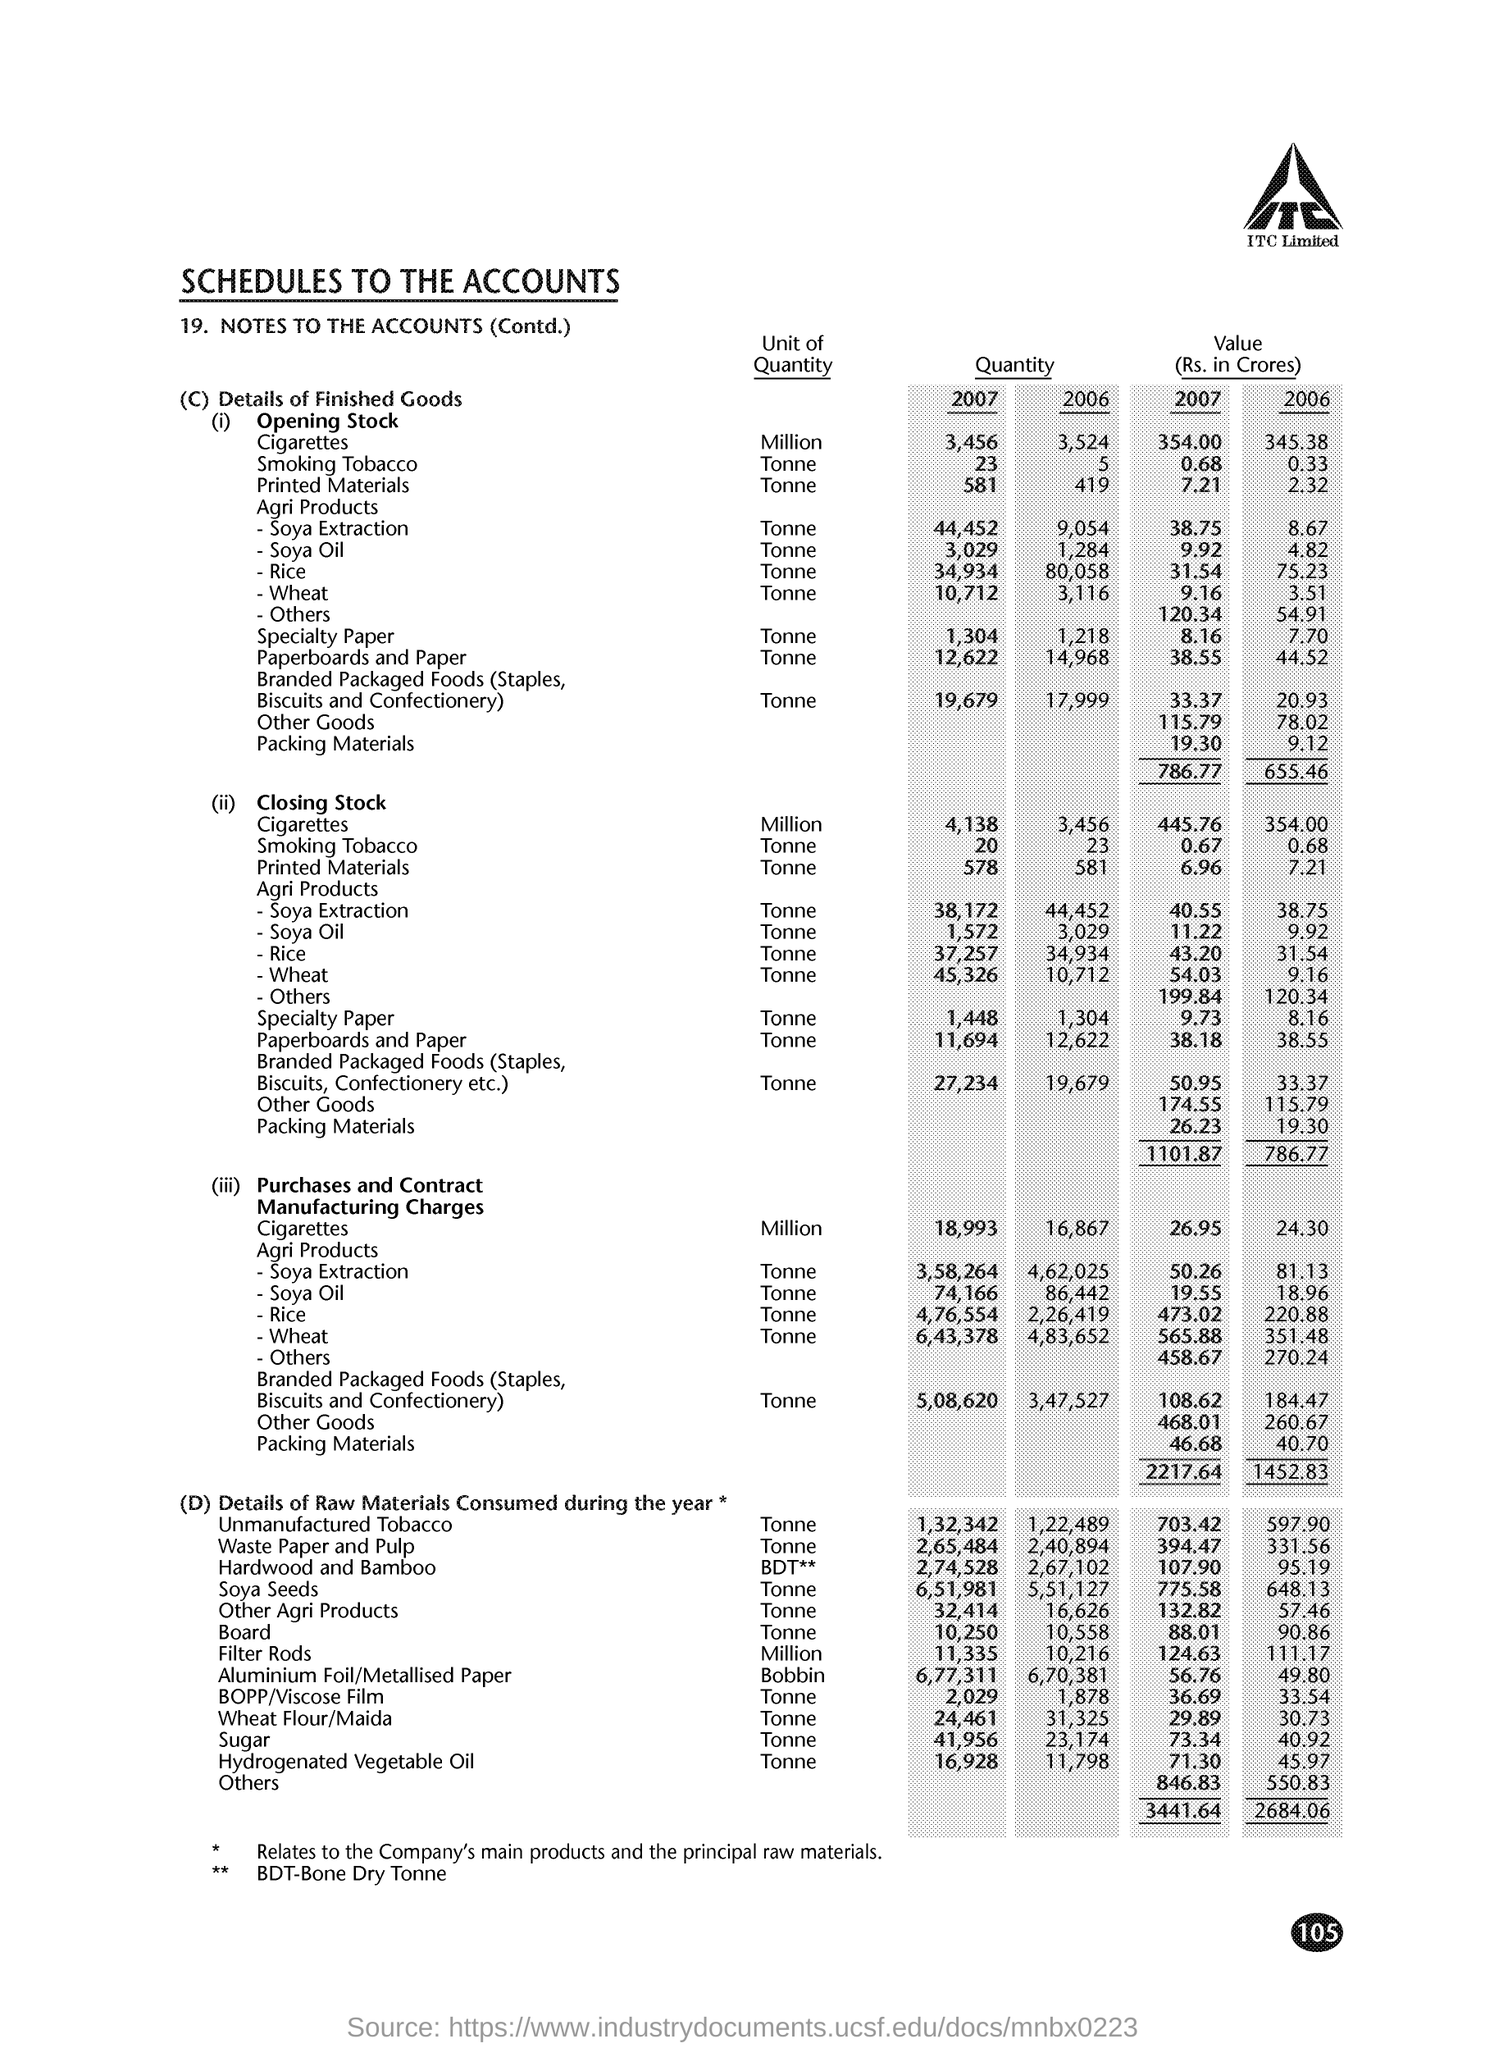What does BDT stand for?
Make the answer very short. Bone dry tonne. What is the document title?
Make the answer very short. SCHEDULES TO THE ACCOUNTS. 